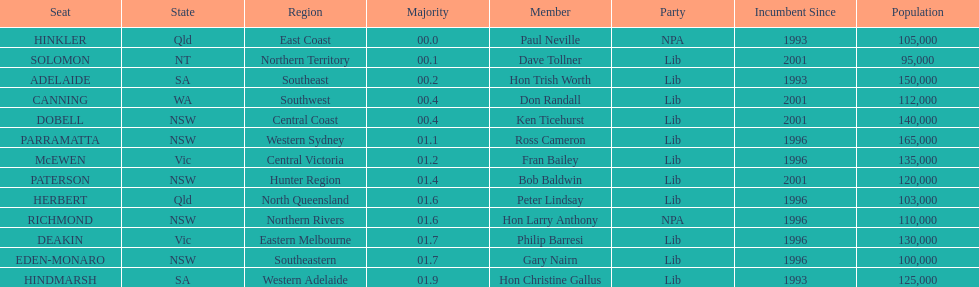What is the name of the last seat? HINDMARSH. 